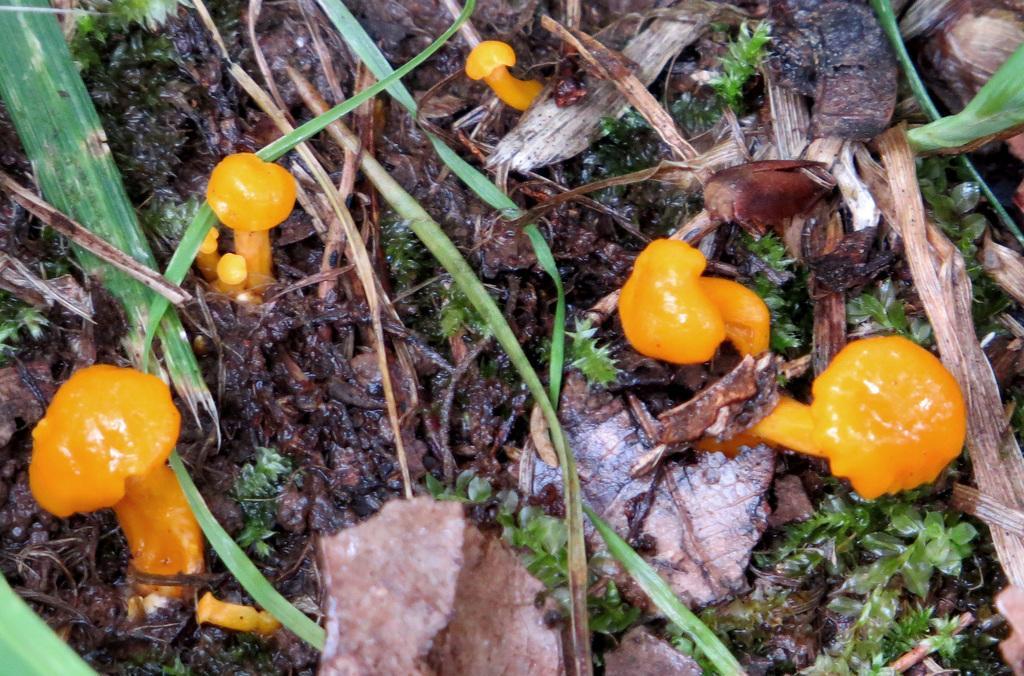How would you summarize this image in a sentence or two? In this picture I can see an orange colored mushrooms, beside that I can see the grass and leaves. 